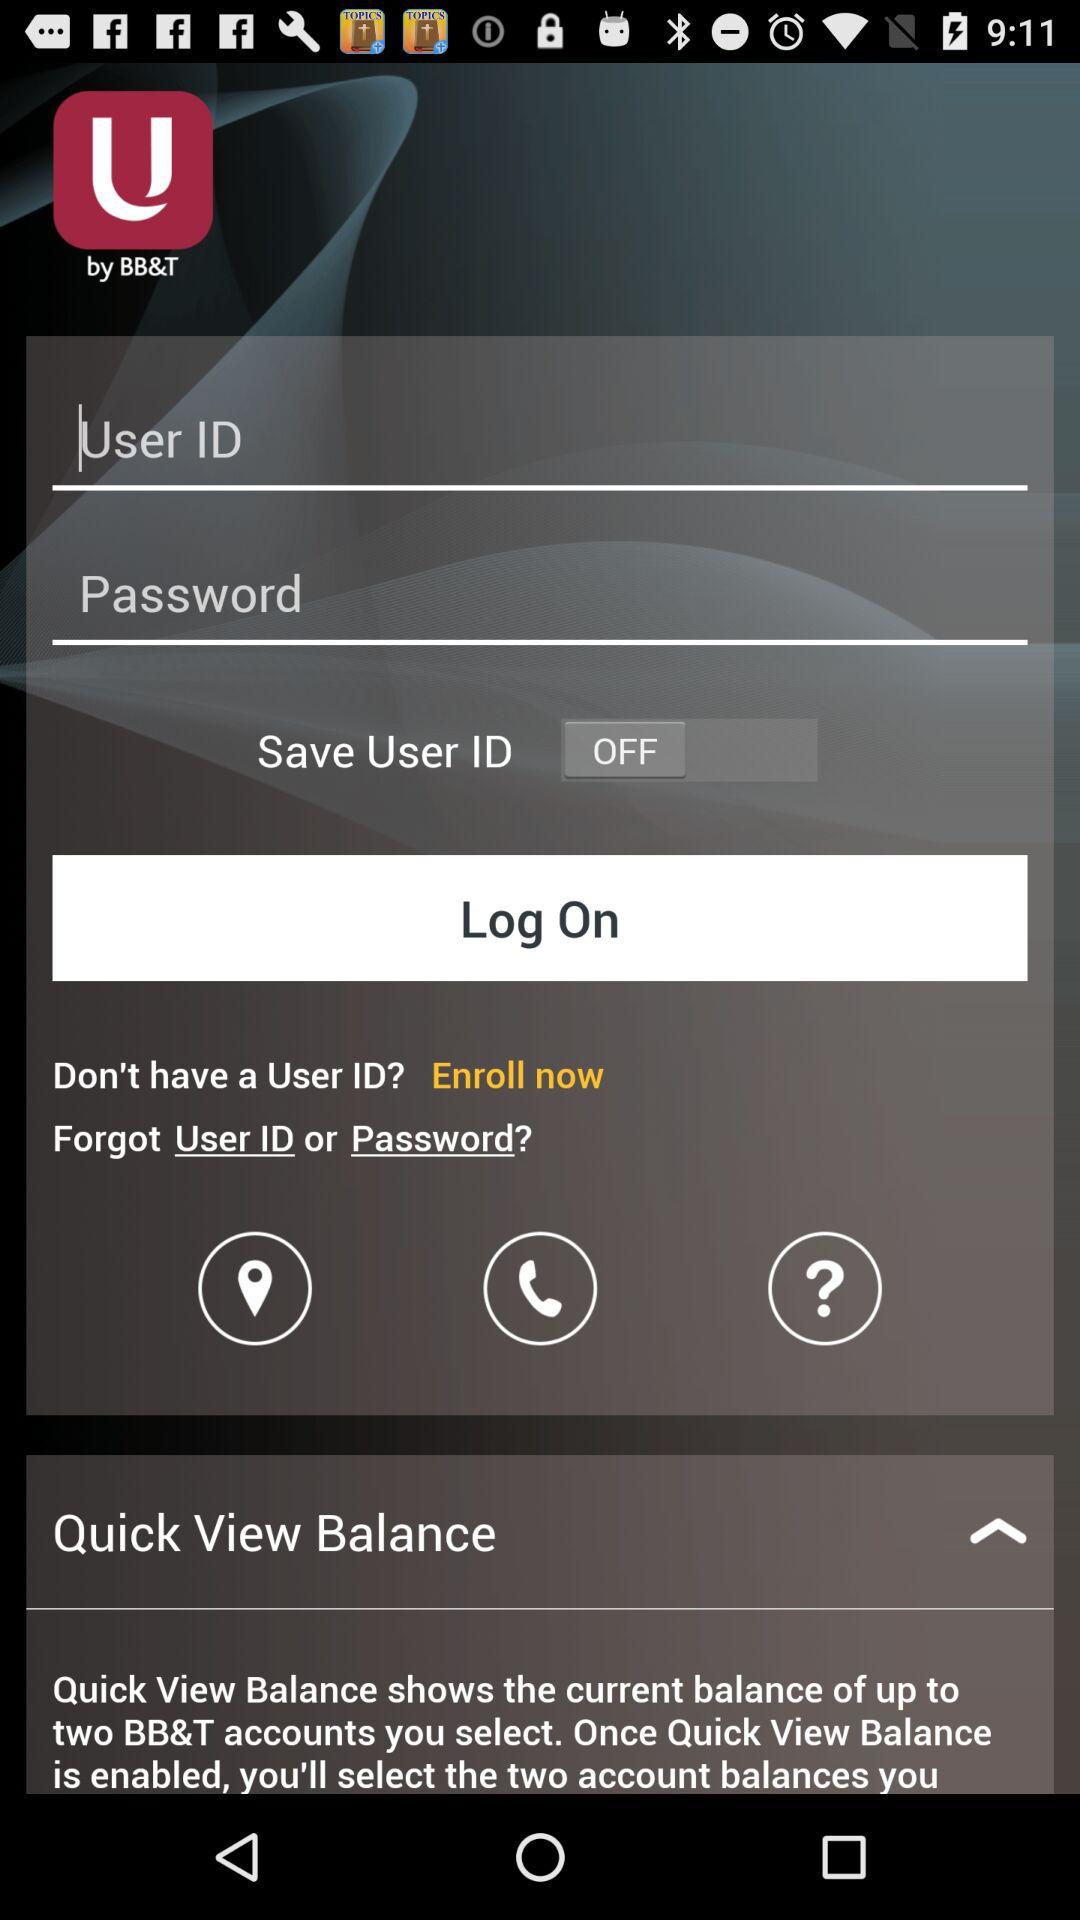What are the requirements to get a log on? The requirements are User ID and Password. 